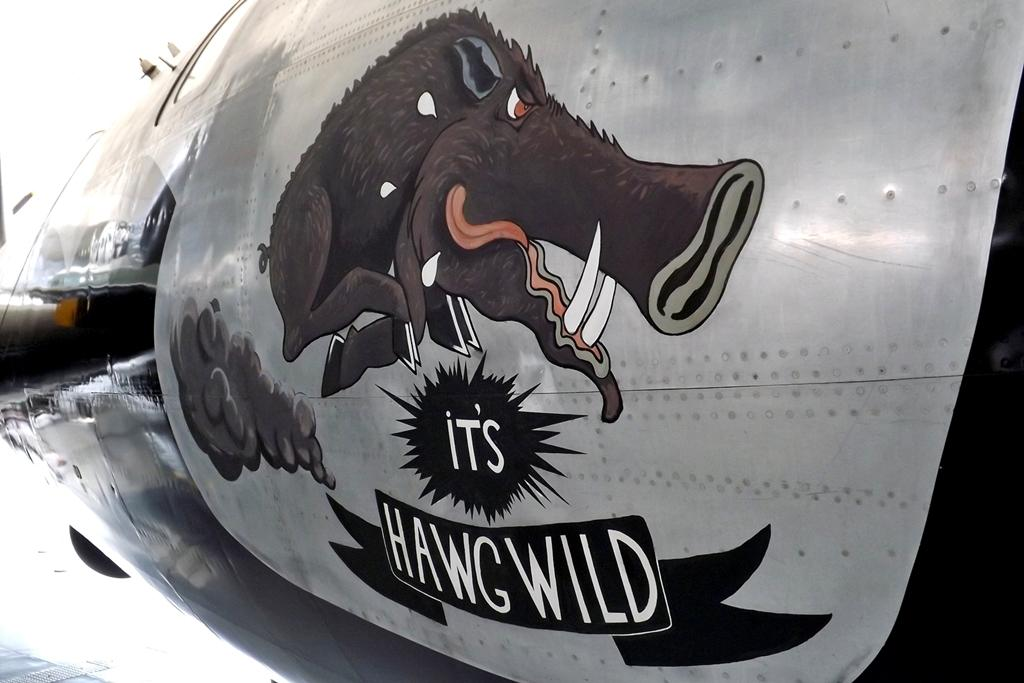What is the main subject of the image? The main subject of the image is an aircraft part. Are there any words or letters on the aircraft part? Yes, there is text on the aircraft part. What else can be seen on the aircraft part besides the text? There is an animal image on the aircraft part. What color is the crayon used to draw the animal image on the aircraft part? There is no crayon present in the image, and therefore no color can be determined for the animal image. 